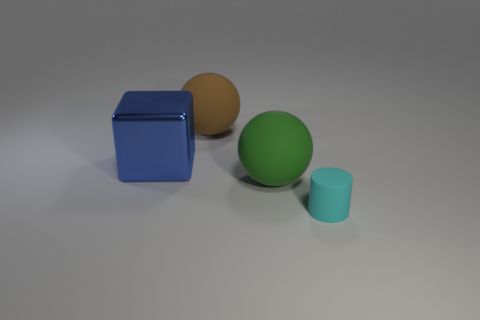Which objects in the image seem closest to the camera? The cyan cylinder appears closest to the camera, followed by the green sphere, the brown sphere, and finally the blue cube. 